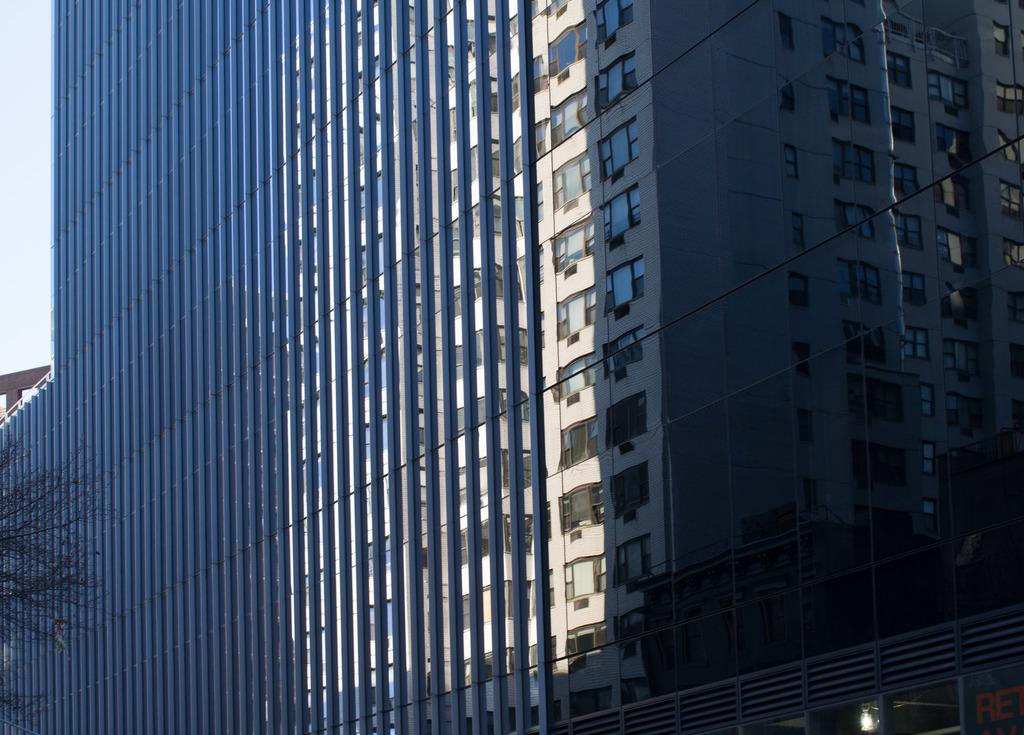What type of structure is visible in the image? There is a building with windows in the image. Where is the tree located in the image? The tree is in the bottom left corner of the image. What type of marble is used to construct the building in the image? There is no mention of marble being used in the construction of the building in the image. 